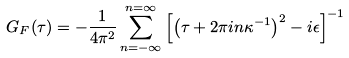Convert formula to latex. <formula><loc_0><loc_0><loc_500><loc_500>G _ { F } ( \tau ) = - \frac { 1 } { 4 \pi ^ { 2 } } \sum _ { n = - \infty } ^ { n = \infty } \left [ \left ( \tau + 2 \pi i n \kappa ^ { - 1 } \right ) ^ { 2 } - i \epsilon \right ] ^ { - 1 }</formula> 